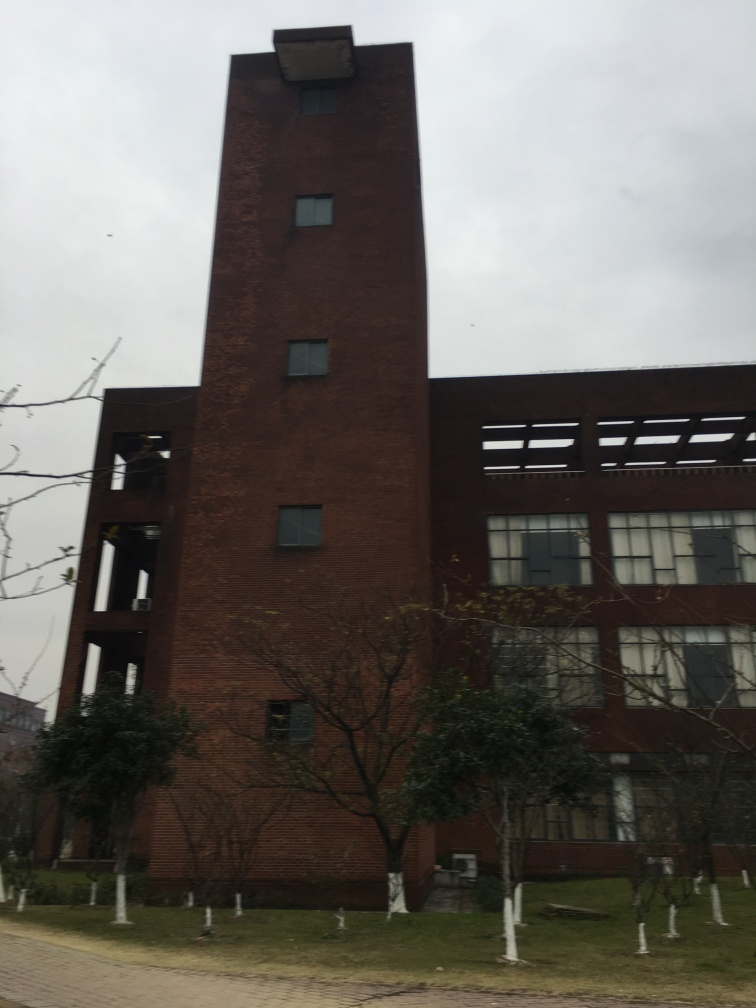Is the quality of this photo unacceptable?
A. Yes
B. No
Answer with the option's letter from the given choices directly.
 B. 